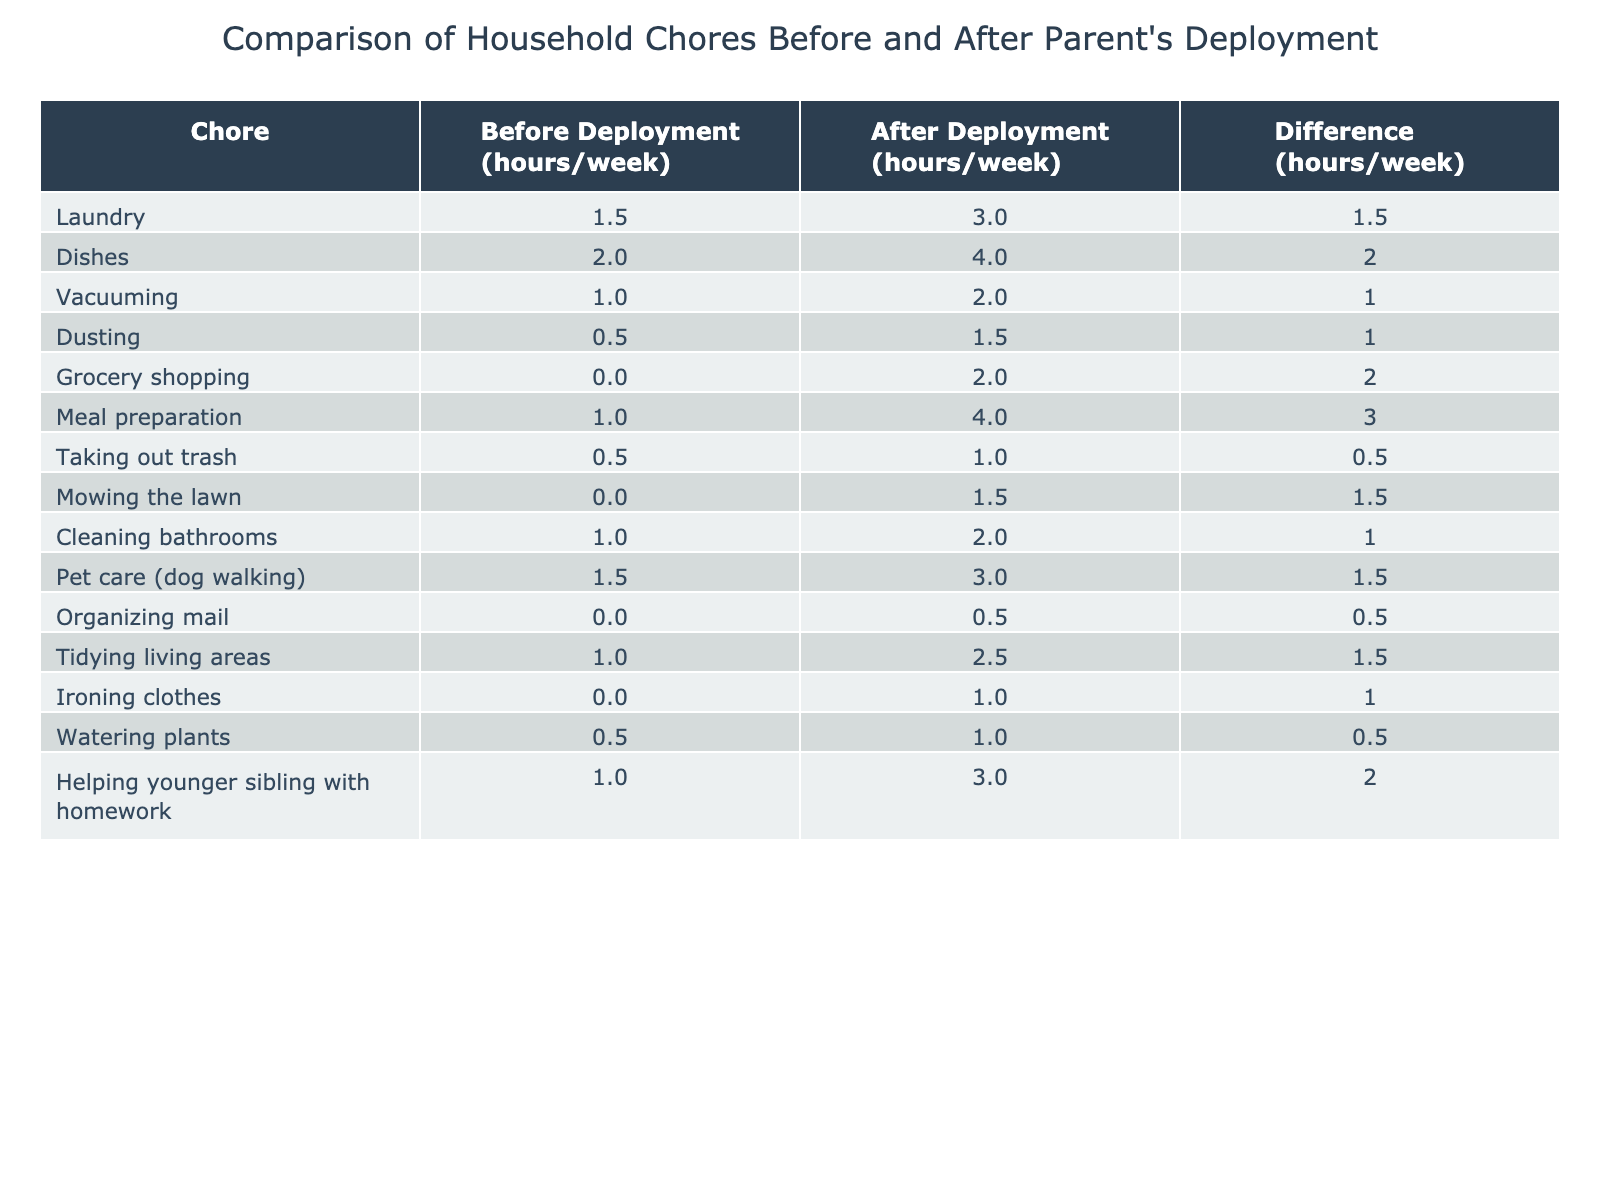What is the total number of hours spent on laundry before deployment? From the table, the number of hours spent on laundry before deployment is listed as 1.5 hours/week.
Answer: 1.5 hours/week How many more hours are spent on meal preparation after deployment compared to before? The table shows that meal preparation took 1 hour/week before deployment and 4 hours/week after deployment. To find the difference, subtract 1 from 4, which equals 3 hours.
Answer: 3 hours Which chore has the largest increase in hours spent after deployment? By comparing the differences in hours for each chore: Laundry increased by 1.5 hours, Dishes by 2 hours, Meal preparation by 3 hours, and Pet care by 1.5 hours. The largest increase is for Meal preparation, with an increase of 3 hours.
Answer: Meal preparation Is there a chore that requires the same amount of time before and after deployment? The table indicates that for Organizing mail, 0 hours/week were spent before deployment, and 0.5 hours/week after deployment. This means there isn't a chore that requires the same time before and after deployment as there is an increase for all.
Answer: No Calculate the average weekly hours spent on chores before deployment. To find the average, sum the hours spent on all chores before deployment: 1.5 + 2 + 1 + 0.5 + 0 + 1 + 0.5 + 0 + 1 + 1.5 + 0 + 1 + 0.5 + 1 + 1 = 12. The number of chores is 15, so the average is 12/15 = 0.8 hours/week.
Answer: 0.8 hours/week What percentage of chores has more hours spent after deployment compared to before? There are 15 chores in total. Counting the ones where hours increased after deployment gives 13 chores. Therefore, to find the percentage, divide 13 by 15 and multiply by 100, resulting in about 86.67%.
Answer: Approximately 86.67% Which chore required less than one hour both before and after deployment? The table shows that Organizing mail was 0 hours/week before deployment and 0.5 hours/week after deployment. Therefore, it is the only chore that required less than one hour in both cases.
Answer: Organizing mail Did any chores decrease in the time spent after deployment? By reviewing the table, all chores show an increase in time spent after deployment. Therefore, no chores decreased in the time spent.
Answer: No How many chores require at least 2 hours/week after deployment? Referring to the table, the chores that take at least 2 hours/week after deployment are Dishes (4), Meal preparation (4), Cleaning bathrooms (2), Tidying living areas (2.5), and Laundry (3). Adding these gives 5 chores.
Answer: 5 chores 